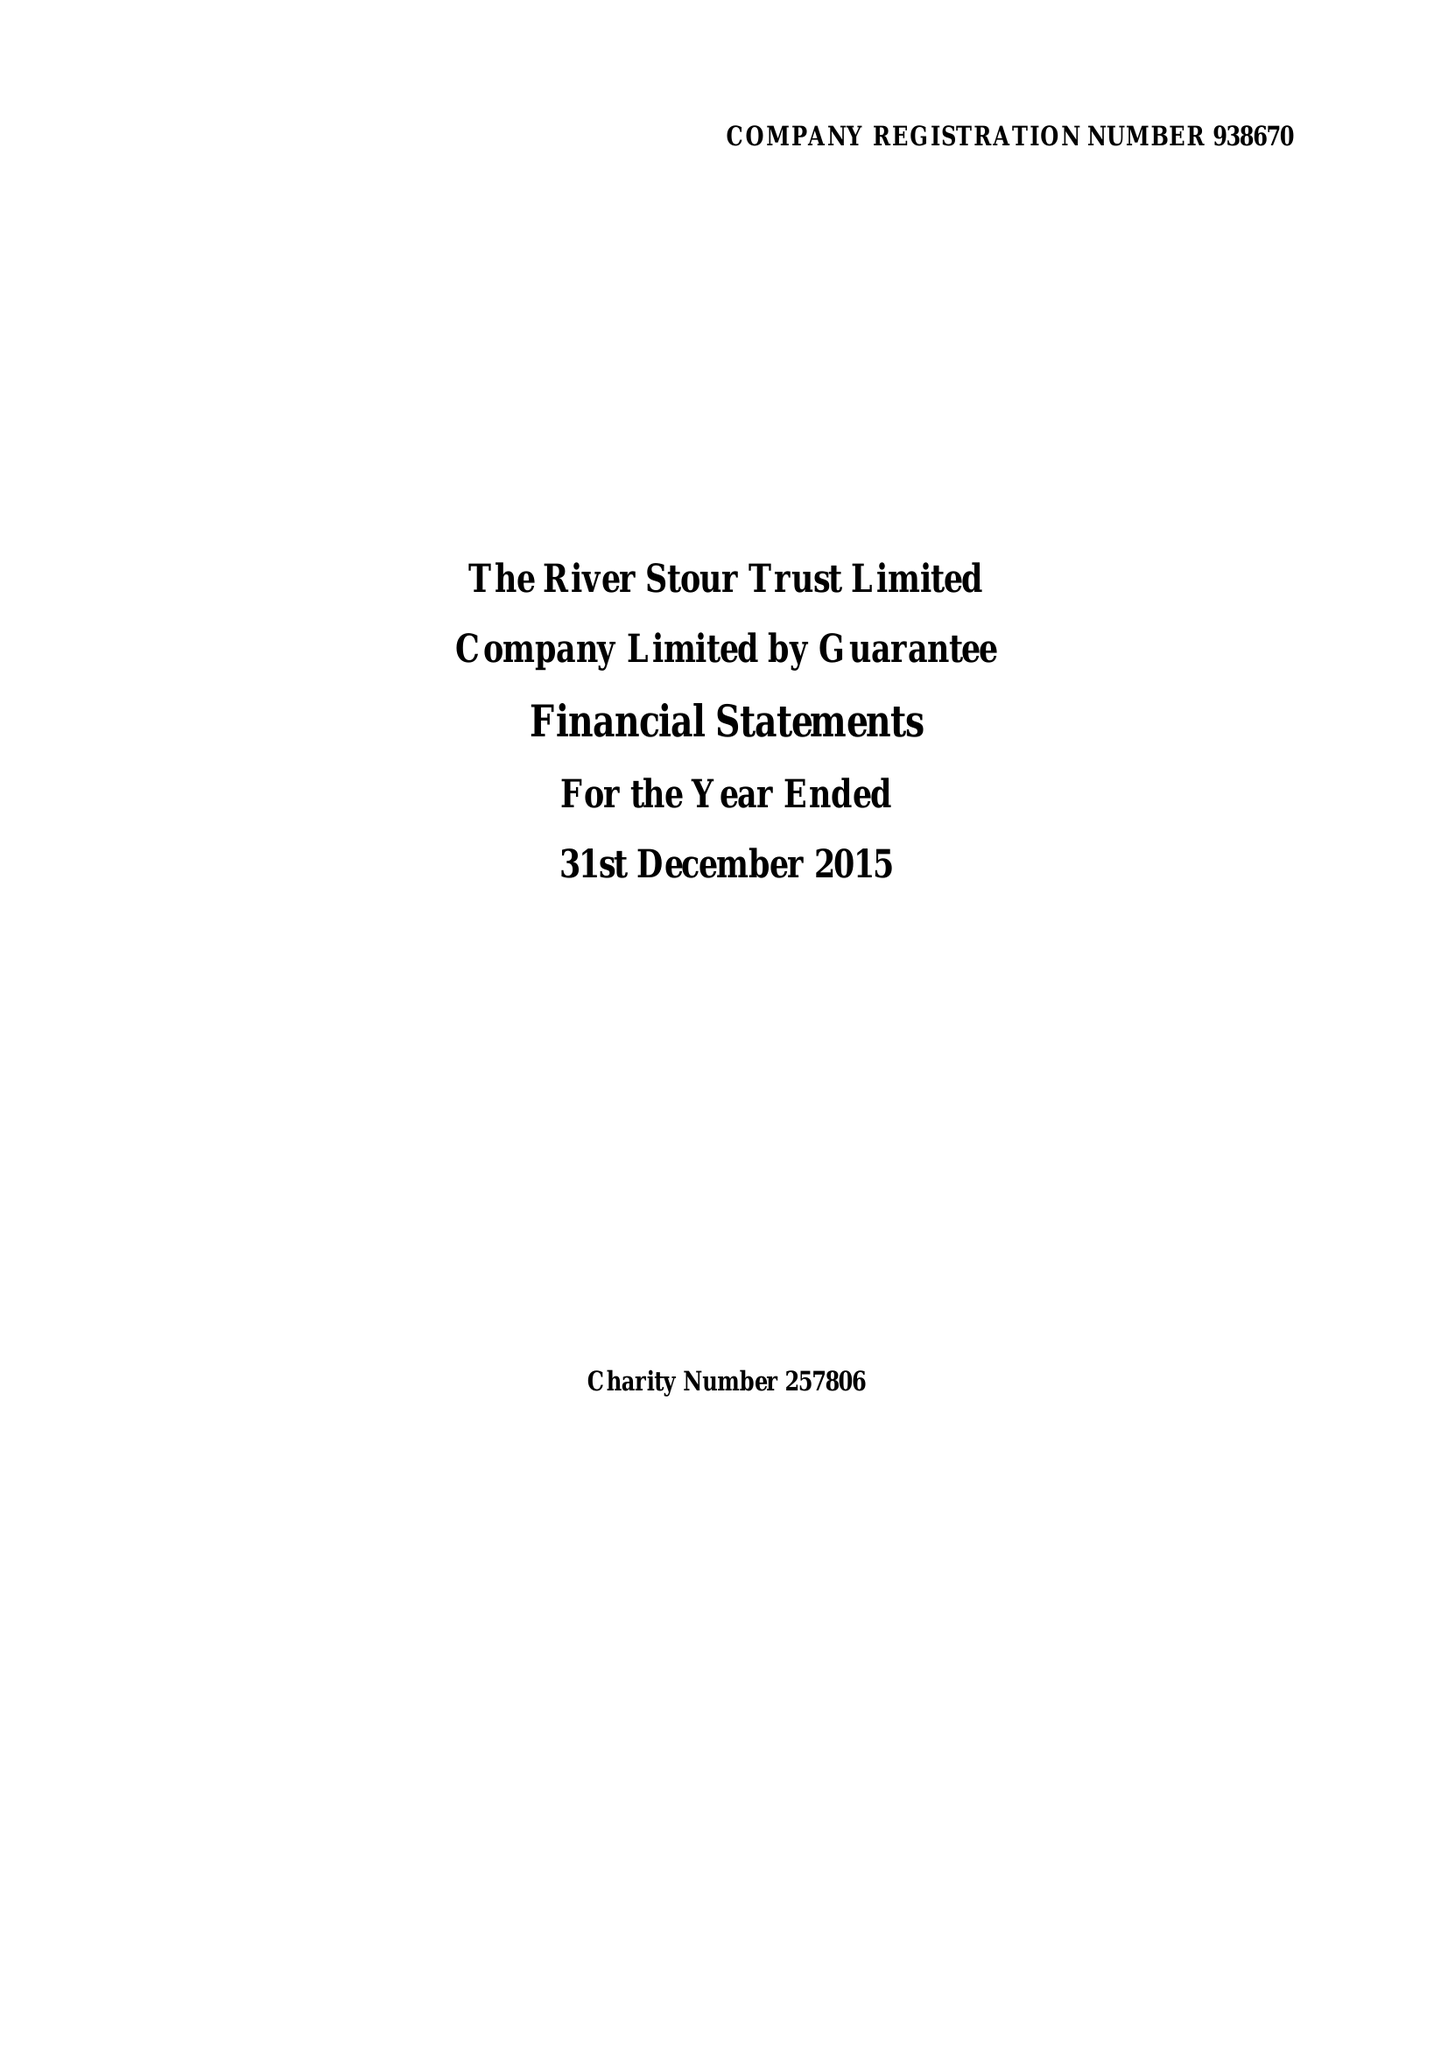What is the value for the address__street_line?
Answer the question using a single word or phrase. None 